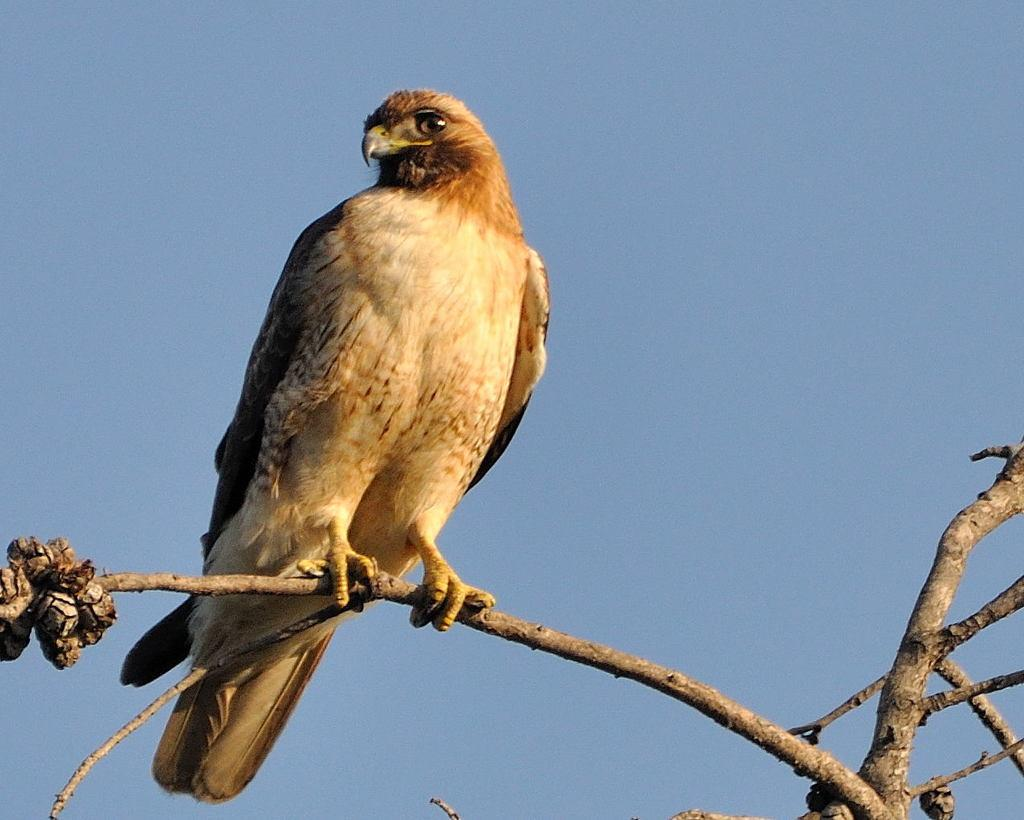What can be seen growing in the image? There are stems in the image. Is there any wildlife present on the stems? Yes, there is a bird on a stem in the image. What can be seen in the background of the image? The sky is visible in the background of the image. How would you describe the weather based on the appearance of the sky? The sky appears to be clear, suggesting good weather. What type of breakfast is the bird eating in the image? There is no breakfast present in the image; it features a bird on a stem with a clear sky in the background. 